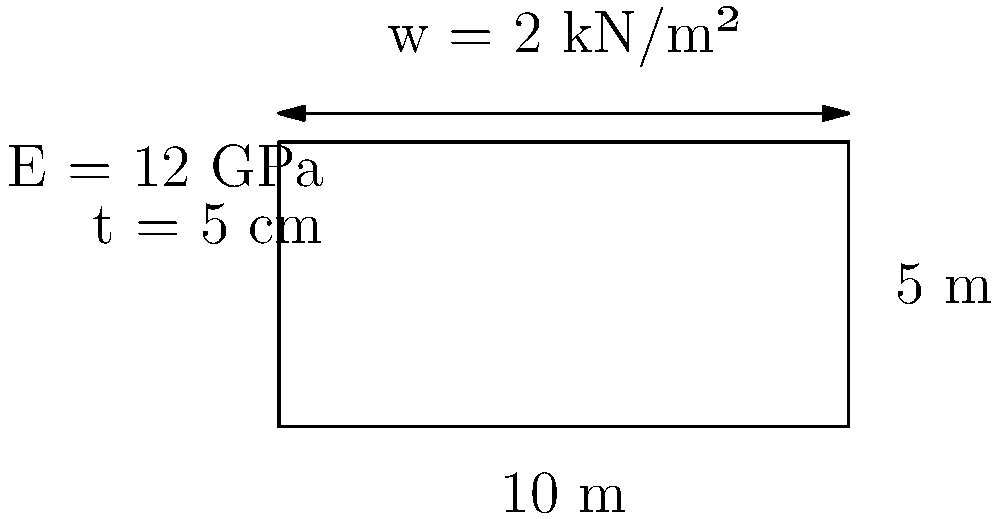As a coach with experience on basketball courts, you're overseeing the installation of a new court floor. The court measures 10 m x 5 m and is subjected to a uniform distributed load of 2 kN/m². The floor is made of engineered wood with a Young's modulus (E) of 12 GPa and a thickness (t) of 5 cm. Calculate the maximum deflection at the center of the floor, assuming it's simply supported on all sides. Use the following formula for maximum deflection of a rectangular plate:

$$ w_{max} = \frac{0.1422 q a^4}{E t^3} $$

Where:
$w_{max}$ = maximum deflection
$q$ = uniform distributed load
$a$ = shorter side length
$E$ = Young's modulus
$t$ = thickness To calculate the maximum deflection, we'll follow these steps:

1. Identify the given values:
   $q = 2$ kN/m² = $2000$ N/m²
   $a = 5$ m (shorter side)
   $E = 12$ GPa = $12 \times 10^9$ Pa
   $t = 5$ cm = $0.05$ m

2. Substitute these values into the formula:

   $$ w_{max} = \frac{0.1422 \times 2000 \times 5^4}{12 \times 10^9 \times 0.05^3} $$

3. Calculate the numerator:
   $0.1422 \times 2000 \times 5^4 = 0.1422 \times 2000 \times 625 = 177,750$

4. Calculate the denominator:
   $12 \times 10^9 \times 0.05^3 = 12 \times 10^9 \times 0.000125 = 1,500,000$

5. Divide:
   $$ w_{max} = \frac{177,750}{1,500,000} = 0.1185 \text{ m} = 118.5 \text{ mm} $$

Therefore, the maximum deflection at the center of the floor is approximately 118.5 mm or 11.85 cm.
Answer: 118.5 mm 